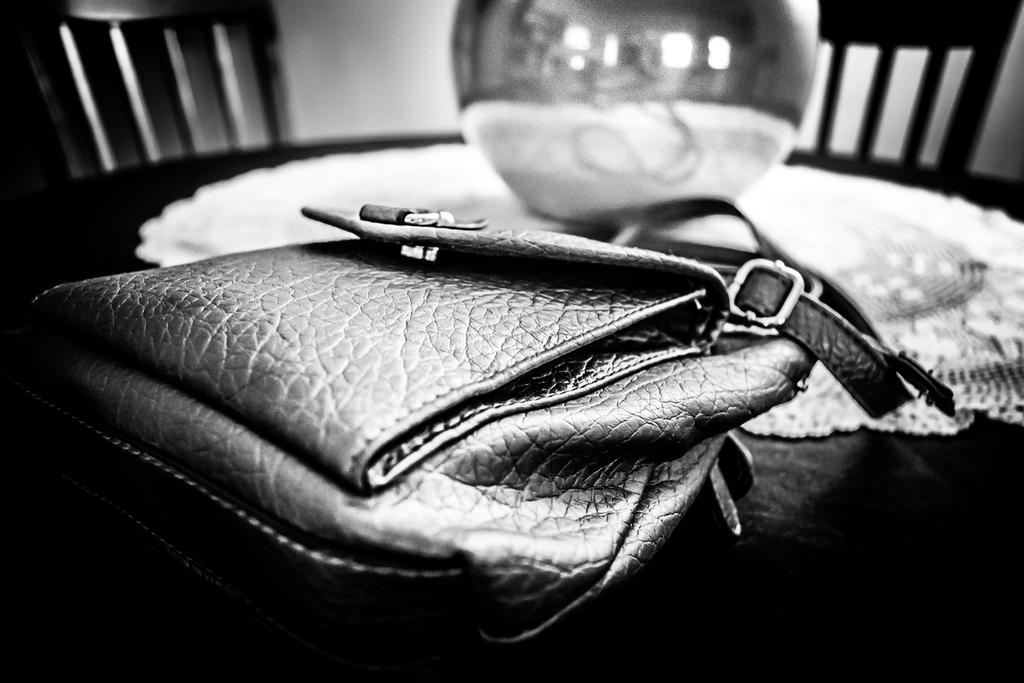What is the color scheme of the image? The image is black and white. What piece of furniture is present in the image? There is a table in the image. What object is on the table? There is a backpack and a round object on the table. What type of material is on the table? There is cloth on the table. What can be seen at the top of the image? There are chairs and a wall visible at the top of the image. How does the daughter feel about the view from the window in the image? There is no daughter or window present in the image, so it is not possible to answer that question. 